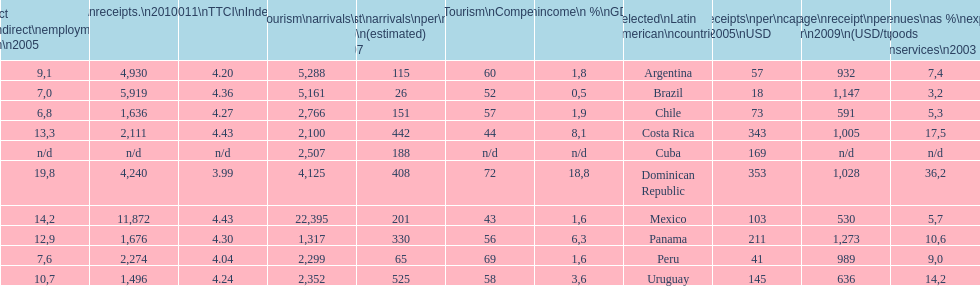How many dollars on average did brazil receive per tourist in 2009? 1,147. 